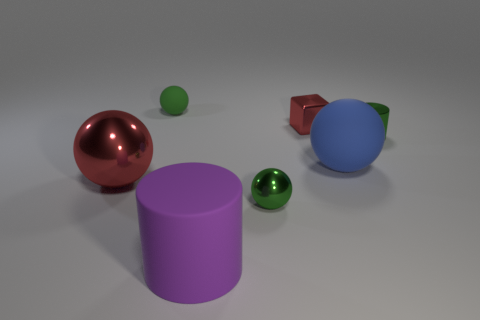Subtract all yellow spheres. Subtract all green cylinders. How many spheres are left? 4 Add 3 cyan balls. How many objects exist? 10 Subtract all balls. How many objects are left? 3 Add 6 red metallic things. How many red metallic things are left? 8 Add 1 tiny blue matte cylinders. How many tiny blue matte cylinders exist? 1 Subtract 0 yellow cylinders. How many objects are left? 7 Subtract all green metal things. Subtract all red blocks. How many objects are left? 4 